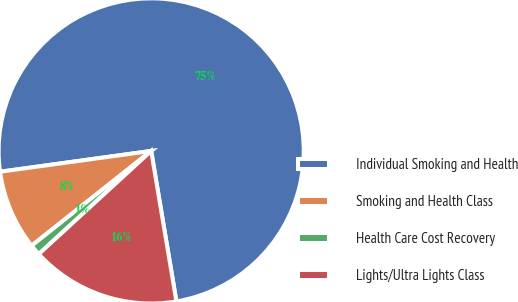Convert chart to OTSL. <chart><loc_0><loc_0><loc_500><loc_500><pie_chart><fcel>Individual Smoking and Health<fcel>Smoking and Health Class<fcel>Health Care Cost Recovery<fcel>Lights/Ultra Lights Class<nl><fcel>74.54%<fcel>8.49%<fcel>1.15%<fcel>15.83%<nl></chart> 